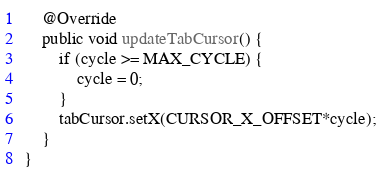<code> <loc_0><loc_0><loc_500><loc_500><_Java_>
    @Override
    public void updateTabCursor() {
        if (cycle >= MAX_CYCLE) {
            cycle = 0;
        }
        tabCursor.setX(CURSOR_X_OFFSET*cycle);
    }
}
</code> 